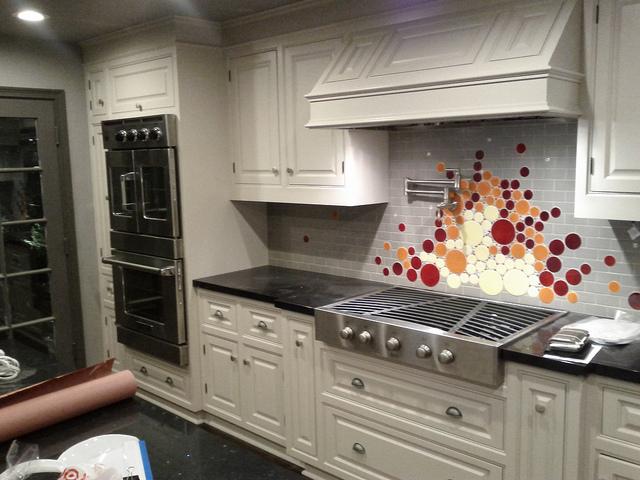How were the patterns of circles put on the kitchen?
Keep it brief. Tile. What color is the tile on the wall?
Quick response, please. White. Does the oven have a dial?
Be succinct. Yes. Is that an electric stove?
Be succinct. No. How many ovens are in this kitchen?
Short answer required. 2. 